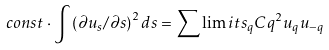Convert formula to latex. <formula><loc_0><loc_0><loc_500><loc_500>c o n s t \cdot \int \left ( \partial u _ { s } / \partial s \right ) ^ { 2 } d s = \sum \lim i t s _ { q } C q ^ { 2 } u _ { q } u _ { - q }</formula> 